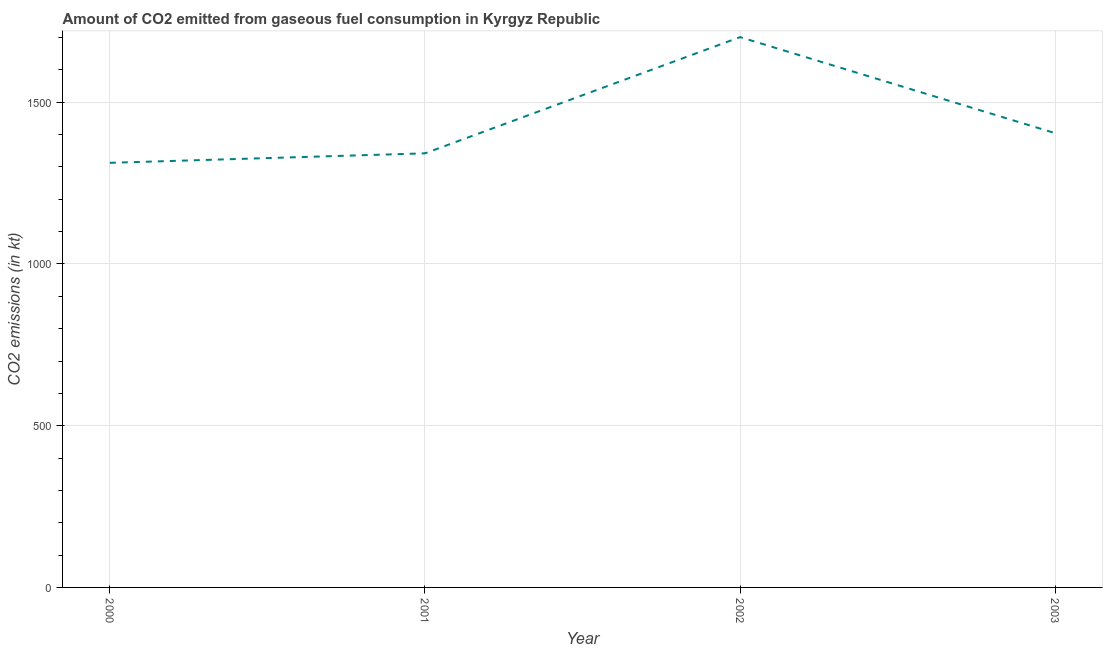What is the co2 emissions from gaseous fuel consumption in 2000?
Provide a succinct answer. 1312.79. Across all years, what is the maximum co2 emissions from gaseous fuel consumption?
Your answer should be compact. 1701.49. Across all years, what is the minimum co2 emissions from gaseous fuel consumption?
Ensure brevity in your answer.  1312.79. In which year was the co2 emissions from gaseous fuel consumption maximum?
Offer a very short reply. 2002. In which year was the co2 emissions from gaseous fuel consumption minimum?
Offer a terse response. 2000. What is the sum of the co2 emissions from gaseous fuel consumption?
Provide a succinct answer. 5760.86. What is the difference between the co2 emissions from gaseous fuel consumption in 2000 and 2001?
Your answer should be very brief. -29.34. What is the average co2 emissions from gaseous fuel consumption per year?
Keep it short and to the point. 1440.21. What is the median co2 emissions from gaseous fuel consumption?
Keep it short and to the point. 1373.29. In how many years, is the co2 emissions from gaseous fuel consumption greater than 300 kt?
Offer a terse response. 4. Do a majority of the years between 2003 and 2000 (inclusive) have co2 emissions from gaseous fuel consumption greater than 1200 kt?
Provide a short and direct response. Yes. What is the ratio of the co2 emissions from gaseous fuel consumption in 2002 to that in 2003?
Your response must be concise. 1.21. What is the difference between the highest and the second highest co2 emissions from gaseous fuel consumption?
Your answer should be compact. 297.03. What is the difference between the highest and the lowest co2 emissions from gaseous fuel consumption?
Give a very brief answer. 388.7. In how many years, is the co2 emissions from gaseous fuel consumption greater than the average co2 emissions from gaseous fuel consumption taken over all years?
Offer a terse response. 1. How many years are there in the graph?
Provide a short and direct response. 4. Does the graph contain grids?
Provide a short and direct response. Yes. What is the title of the graph?
Your response must be concise. Amount of CO2 emitted from gaseous fuel consumption in Kyrgyz Republic. What is the label or title of the Y-axis?
Provide a short and direct response. CO2 emissions (in kt). What is the CO2 emissions (in kt) in 2000?
Ensure brevity in your answer.  1312.79. What is the CO2 emissions (in kt) of 2001?
Keep it short and to the point. 1342.12. What is the CO2 emissions (in kt) in 2002?
Keep it short and to the point. 1701.49. What is the CO2 emissions (in kt) in 2003?
Keep it short and to the point. 1404.46. What is the difference between the CO2 emissions (in kt) in 2000 and 2001?
Provide a short and direct response. -29.34. What is the difference between the CO2 emissions (in kt) in 2000 and 2002?
Offer a terse response. -388.7. What is the difference between the CO2 emissions (in kt) in 2000 and 2003?
Provide a succinct answer. -91.67. What is the difference between the CO2 emissions (in kt) in 2001 and 2002?
Give a very brief answer. -359.37. What is the difference between the CO2 emissions (in kt) in 2001 and 2003?
Offer a very short reply. -62.34. What is the difference between the CO2 emissions (in kt) in 2002 and 2003?
Offer a terse response. 297.03. What is the ratio of the CO2 emissions (in kt) in 2000 to that in 2001?
Make the answer very short. 0.98. What is the ratio of the CO2 emissions (in kt) in 2000 to that in 2002?
Make the answer very short. 0.77. What is the ratio of the CO2 emissions (in kt) in 2000 to that in 2003?
Give a very brief answer. 0.94. What is the ratio of the CO2 emissions (in kt) in 2001 to that in 2002?
Offer a very short reply. 0.79. What is the ratio of the CO2 emissions (in kt) in 2001 to that in 2003?
Provide a short and direct response. 0.96. What is the ratio of the CO2 emissions (in kt) in 2002 to that in 2003?
Your response must be concise. 1.21. 